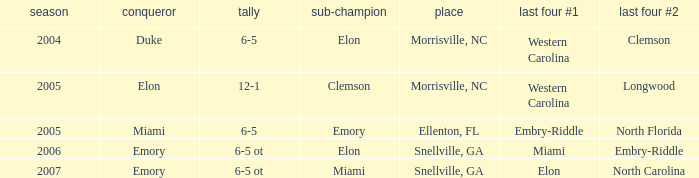How many teams were listed as runner up in 2005 and there the first semi finalist was Western Carolina? 1.0. 